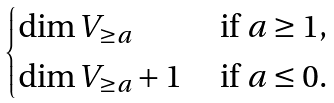Convert formula to latex. <formula><loc_0><loc_0><loc_500><loc_500>\begin{cases} \dim V _ { \geq a } & \text { if $a\geq 1$,} \\ \dim V _ { \geq a } + 1 & \text { if $a\leq 0$.} \end{cases}</formula> 